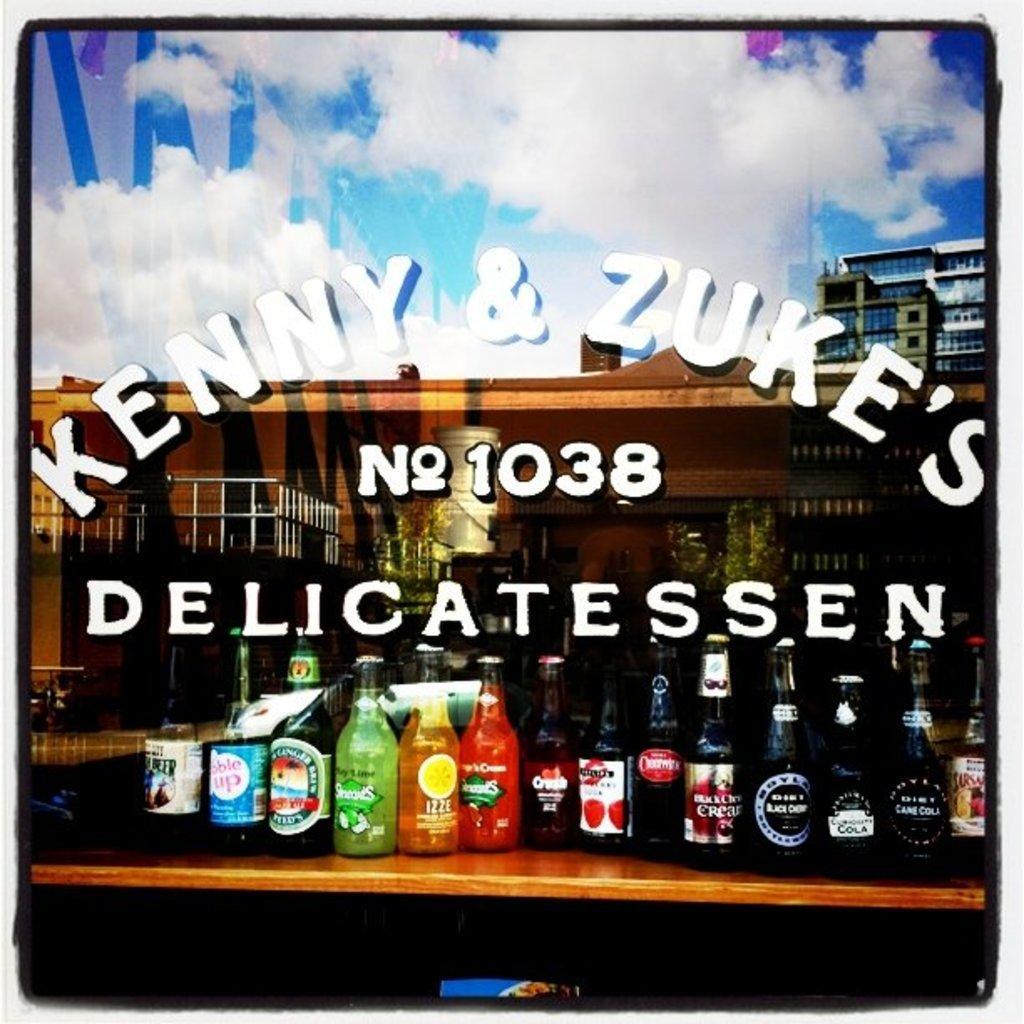Can you describe this image briefly? These are the bottles on the table with labels on it. 